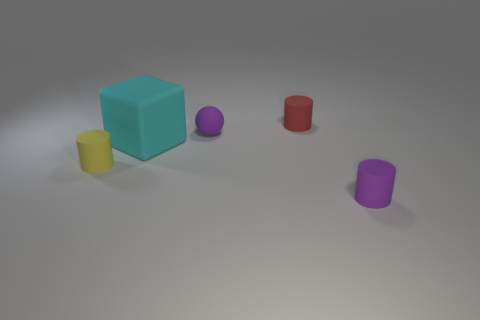Add 1 brown objects. How many objects exist? 6 Subtract all balls. How many objects are left? 4 Subtract 1 purple spheres. How many objects are left? 4 Subtract all tiny red cylinders. Subtract all tiny red cylinders. How many objects are left? 3 Add 4 tiny spheres. How many tiny spheres are left? 5 Add 1 tiny yellow rubber cylinders. How many tiny yellow rubber cylinders exist? 2 